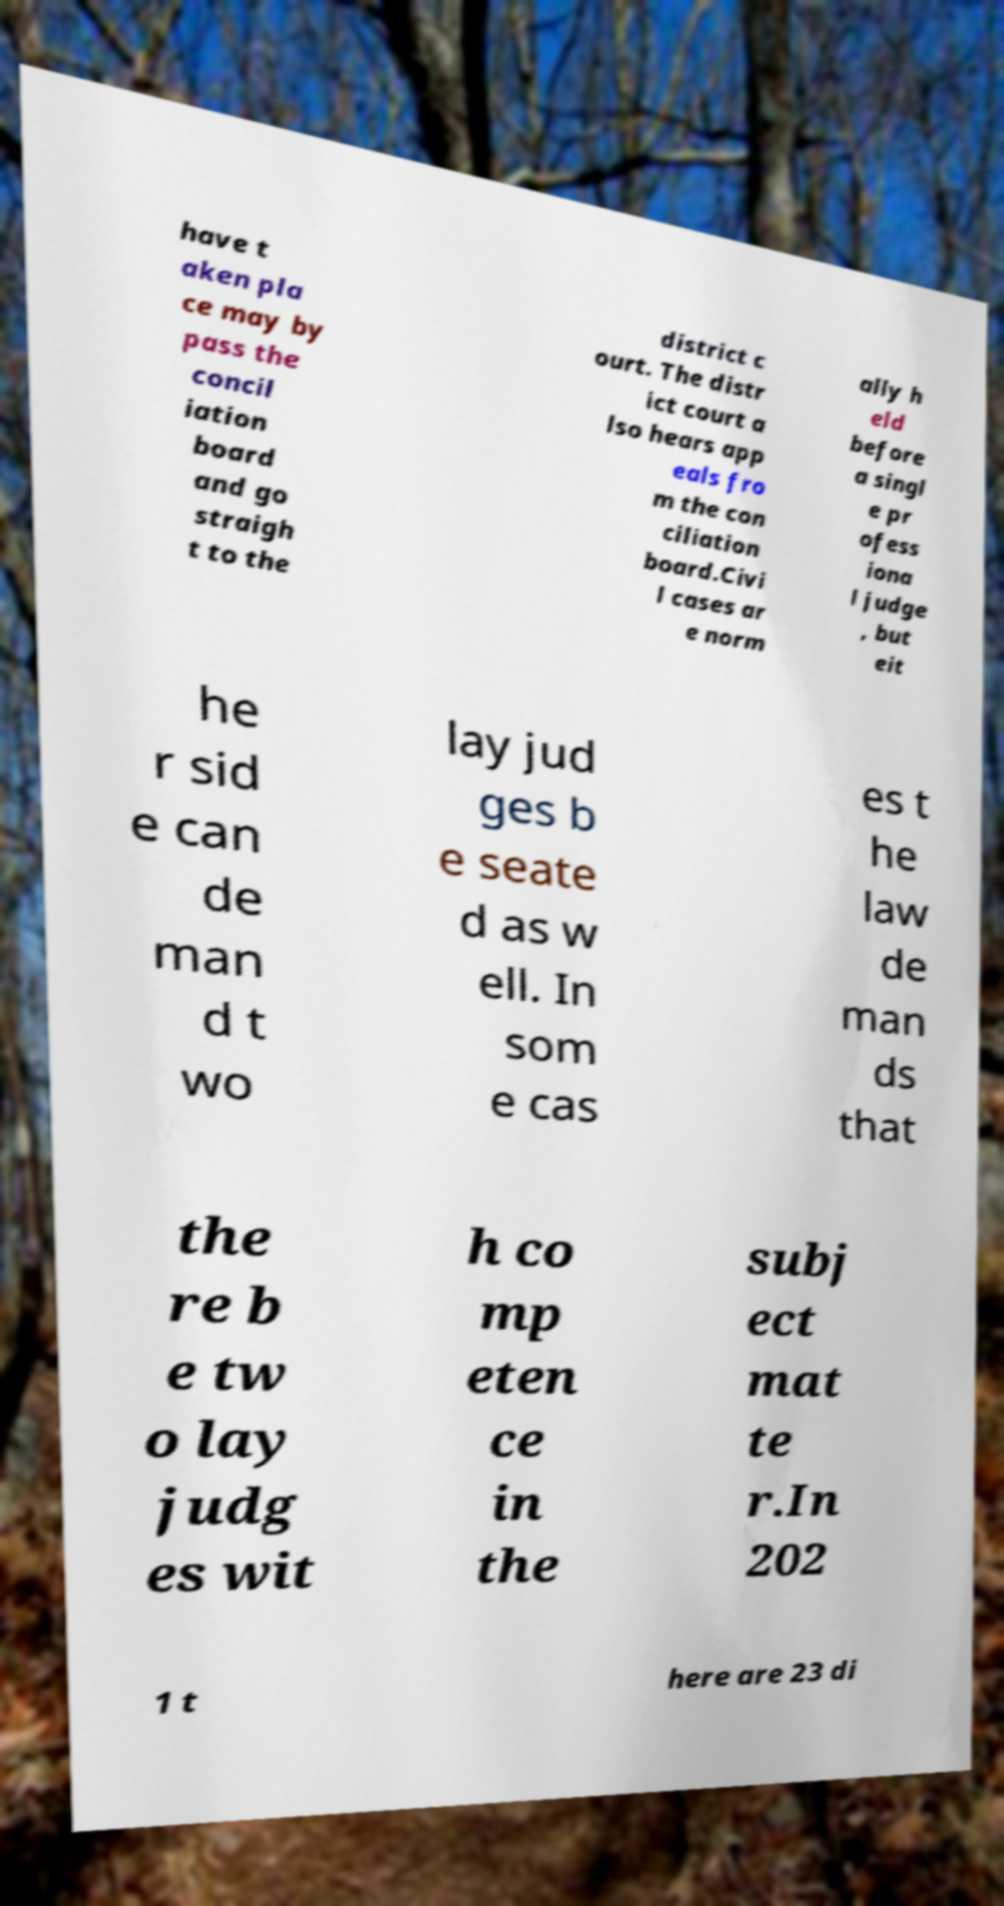For documentation purposes, I need the text within this image transcribed. Could you provide that? have t aken pla ce may by pass the concil iation board and go straigh t to the district c ourt. The distr ict court a lso hears app eals fro m the con ciliation board.Civi l cases ar e norm ally h eld before a singl e pr ofess iona l judge , but eit he r sid e can de man d t wo lay jud ges b e seate d as w ell. In som e cas es t he law de man ds that the re b e tw o lay judg es wit h co mp eten ce in the subj ect mat te r.In 202 1 t here are 23 di 